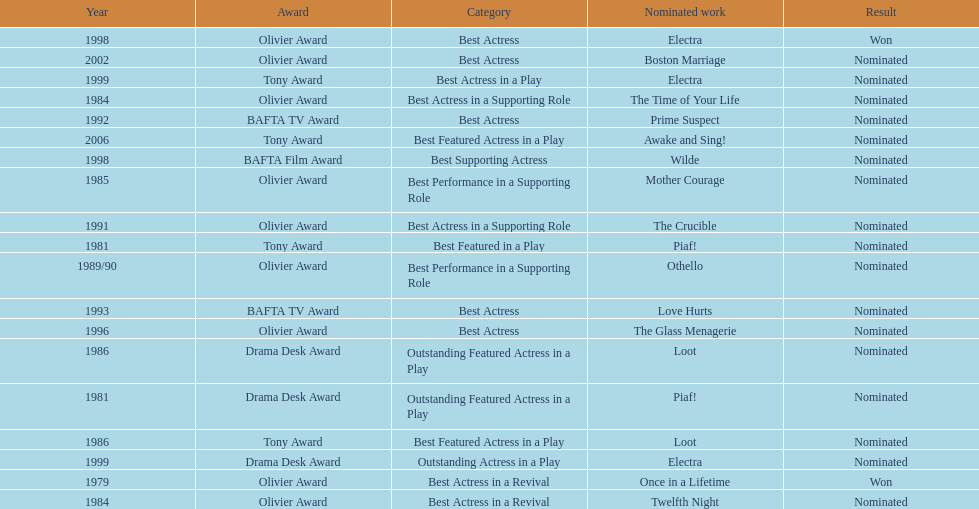What year was prime suspects nominated for the bafta tv award? 1992. 